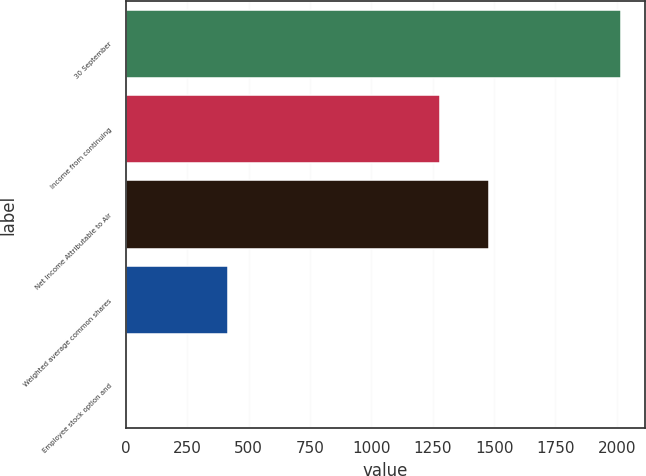<chart> <loc_0><loc_0><loc_500><loc_500><bar_chart><fcel>30 September<fcel>Income from continuing<fcel>Net Income Attributable to Air<fcel>Weighted average common shares<fcel>Employee stock option and<nl><fcel>2015<fcel>1277.9<fcel>1479.16<fcel>416.16<fcel>2.4<nl></chart> 